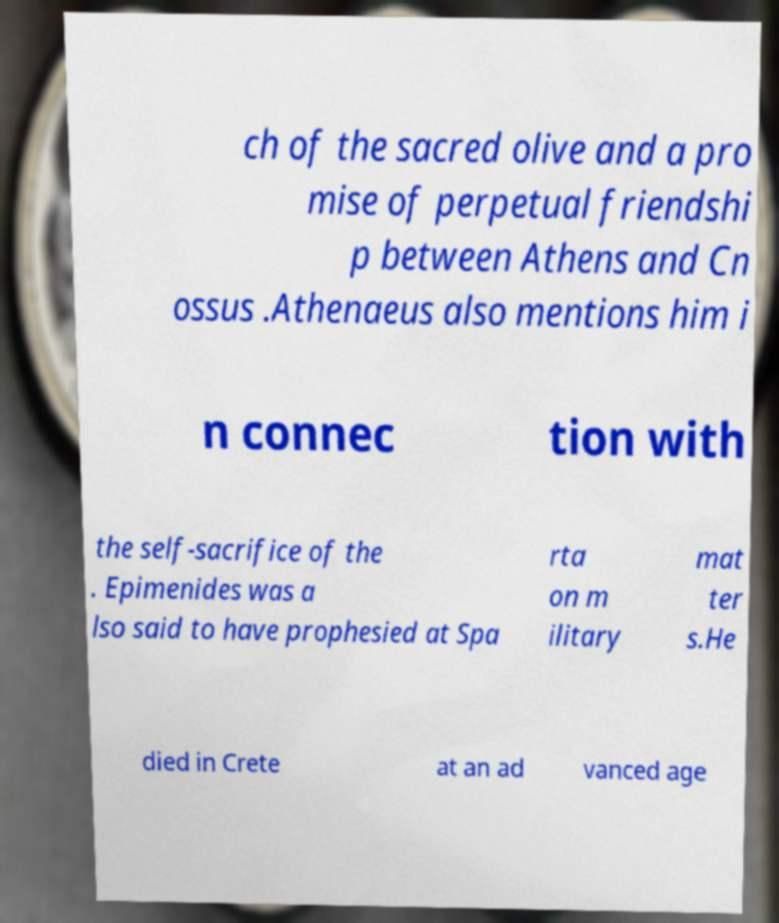Can you accurately transcribe the text from the provided image for me? ch of the sacred olive and a pro mise of perpetual friendshi p between Athens and Cn ossus .Athenaeus also mentions him i n connec tion with the self-sacrifice of the . Epimenides was a lso said to have prophesied at Spa rta on m ilitary mat ter s.He died in Crete at an ad vanced age 